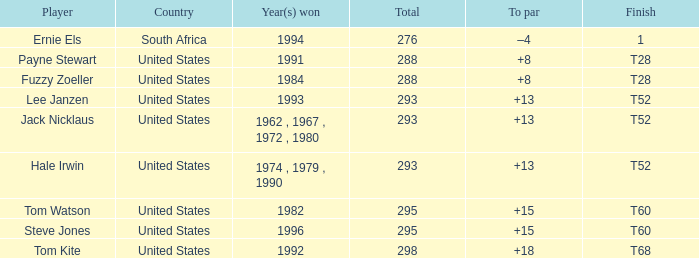Can you identify the player who claimed victory in 1994? Ernie Els. 